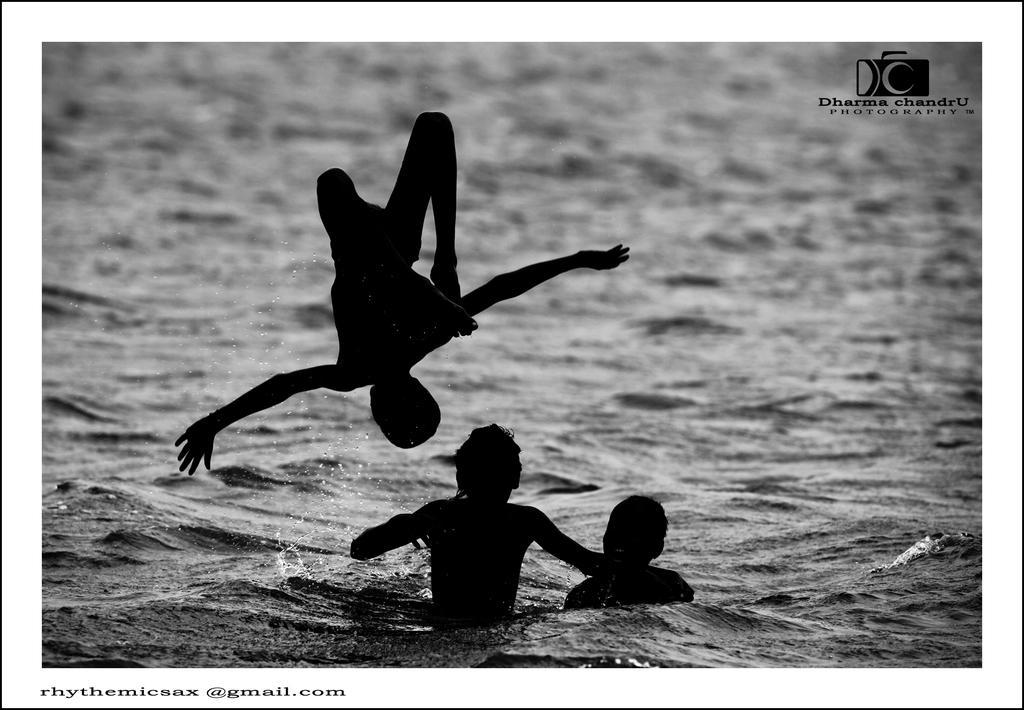Please provide a concise description of this image. In this picture we can see two people in the water and one person is in the air, in the top right, bottom left we can see a logo and some text on it. 